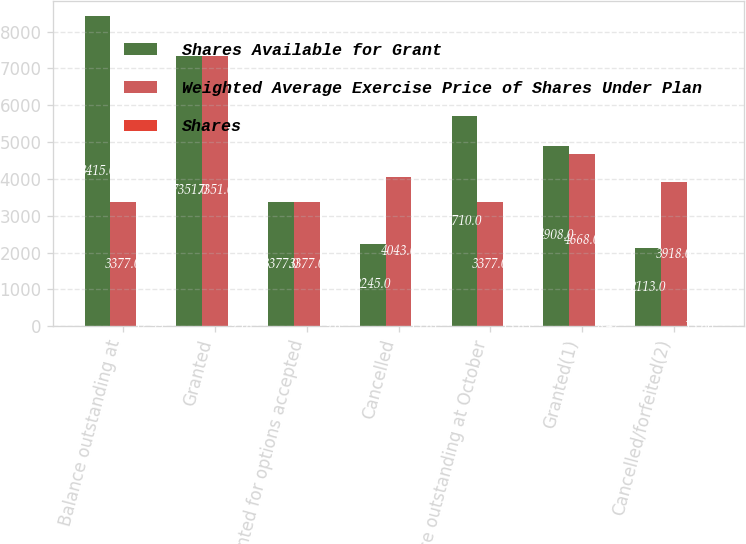Convert chart. <chart><loc_0><loc_0><loc_500><loc_500><stacked_bar_chart><ecel><fcel>Balance outstanding at<fcel>Granted<fcel>Granted for options accepted<fcel>Cancelled<fcel>Balance outstanding at October<fcel>Granted(1)<fcel>Cancelled/forfeited(2)<nl><fcel>Shares Available for Grant<fcel>8415<fcel>7351<fcel>3377<fcel>2245<fcel>5710<fcel>4908<fcel>2113<nl><fcel>Weighted Average Exercise Price of Shares Under Plan<fcel>3377<fcel>7351<fcel>3377<fcel>4043<fcel>3377<fcel>4668<fcel>3918<nl><fcel>Shares<fcel>12.99<fcel>9.16<fcel>9.6<fcel>15.61<fcel>13.63<fcel>8.47<fcel>13.66<nl></chart> 